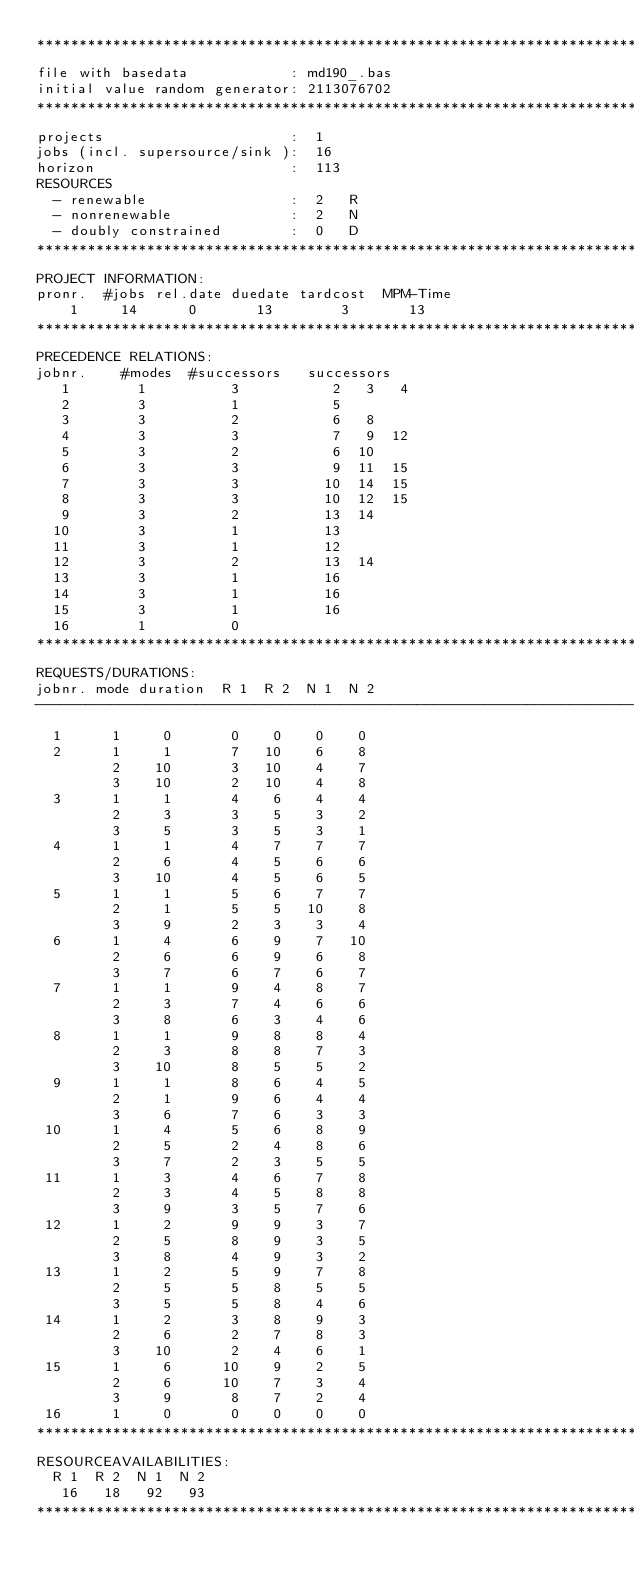<code> <loc_0><loc_0><loc_500><loc_500><_ObjectiveC_>************************************************************************
file with basedata            : md190_.bas
initial value random generator: 2113076702
************************************************************************
projects                      :  1
jobs (incl. supersource/sink ):  16
horizon                       :  113
RESOURCES
  - renewable                 :  2   R
  - nonrenewable              :  2   N
  - doubly constrained        :  0   D
************************************************************************
PROJECT INFORMATION:
pronr.  #jobs rel.date duedate tardcost  MPM-Time
    1     14      0       13        3       13
************************************************************************
PRECEDENCE RELATIONS:
jobnr.    #modes  #successors   successors
   1        1          3           2   3   4
   2        3          1           5
   3        3          2           6   8
   4        3          3           7   9  12
   5        3          2           6  10
   6        3          3           9  11  15
   7        3          3          10  14  15
   8        3          3          10  12  15
   9        3          2          13  14
  10        3          1          13
  11        3          1          12
  12        3          2          13  14
  13        3          1          16
  14        3          1          16
  15        3          1          16
  16        1          0        
************************************************************************
REQUESTS/DURATIONS:
jobnr. mode duration  R 1  R 2  N 1  N 2
------------------------------------------------------------------------
  1      1     0       0    0    0    0
  2      1     1       7   10    6    8
         2    10       3   10    4    7
         3    10       2   10    4    8
  3      1     1       4    6    4    4
         2     3       3    5    3    2
         3     5       3    5    3    1
  4      1     1       4    7    7    7
         2     6       4    5    6    6
         3    10       4    5    6    5
  5      1     1       5    6    7    7
         2     1       5    5   10    8
         3     9       2    3    3    4
  6      1     4       6    9    7   10
         2     6       6    9    6    8
         3     7       6    7    6    7
  7      1     1       9    4    8    7
         2     3       7    4    6    6
         3     8       6    3    4    6
  8      1     1       9    8    8    4
         2     3       8    8    7    3
         3    10       8    5    5    2
  9      1     1       8    6    4    5
         2     1       9    6    4    4
         3     6       7    6    3    3
 10      1     4       5    6    8    9
         2     5       2    4    8    6
         3     7       2    3    5    5
 11      1     3       4    6    7    8
         2     3       4    5    8    8
         3     9       3    5    7    6
 12      1     2       9    9    3    7
         2     5       8    9    3    5
         3     8       4    9    3    2
 13      1     2       5    9    7    8
         2     5       5    8    5    5
         3     5       5    8    4    6
 14      1     2       3    8    9    3
         2     6       2    7    8    3
         3    10       2    4    6    1
 15      1     6      10    9    2    5
         2     6      10    7    3    4
         3     9       8    7    2    4
 16      1     0       0    0    0    0
************************************************************************
RESOURCEAVAILABILITIES:
  R 1  R 2  N 1  N 2
   16   18   92   93
************************************************************************
</code> 